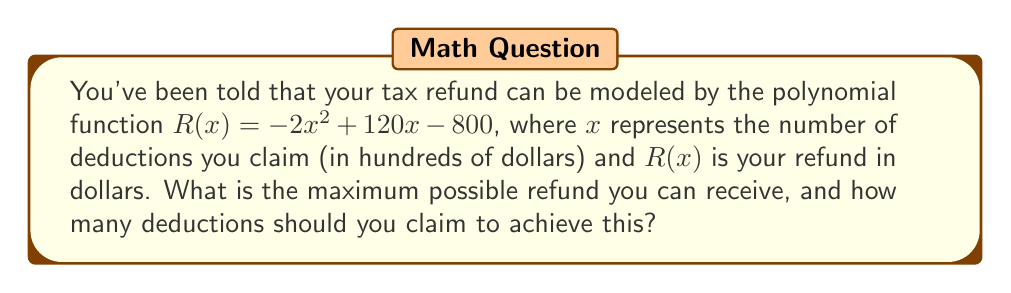Could you help me with this problem? To find the maximum possible refund, we need to optimize the given polynomial function. Here's how we can do this:

1) The function $R(x) = -2x^2 + 120x - 800$ is a quadratic function, which forms a parabola when graphed. Since the coefficient of $x^2$ is negative (-2), this parabola opens downward and has a maximum point.

2) To find the maximum point, we can use calculus or the vertex formula. Let's use the vertex formula since it's simpler:

   For a quadratic function in the form $f(x) = ax^2 + bx + c$, the x-coordinate of the vertex is given by $x = -\frac{b}{2a}$.

3) In our case, $a = -2$, $b = 120$, and $c = -800$. Let's substitute these into the formula:

   $x = -\frac{120}{2(-2)} = -\frac{120}{-4} = 30$

4) This means that the maximum occurs when $x = 30$, or when you claim $3000 in deductions.

5) To find the maximum refund, we substitute $x = 30$ into our original function:

   $R(30) = -2(30)^2 + 120(30) - 800$
          $= -2(900) + 3600 - 800$
          $= -1800 + 3600 - 800$
          $= 1000$

Therefore, the maximum refund is $1000, achieved when claiming $3000 in deductions.
Answer: Maximum refund: $1000; Deductions to claim: $3000 